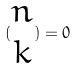<formula> <loc_0><loc_0><loc_500><loc_500>( \begin{matrix} n \\ k \end{matrix} ) = 0</formula> 